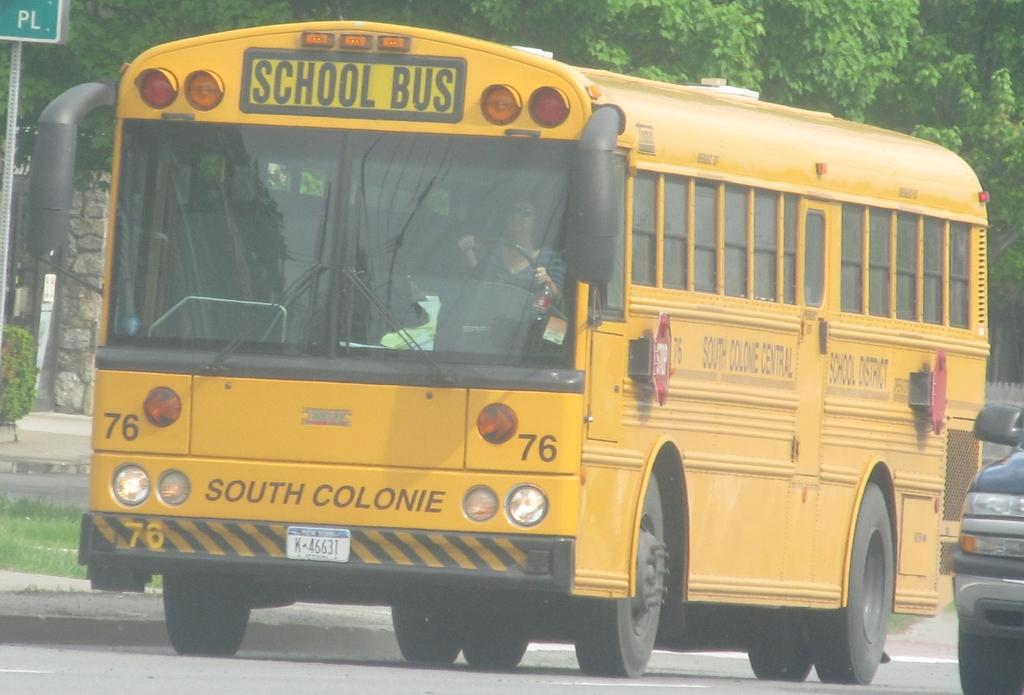<image>
Write a terse but informative summary of the picture. South Colonie yellow school bus is on the highway near a jeep 